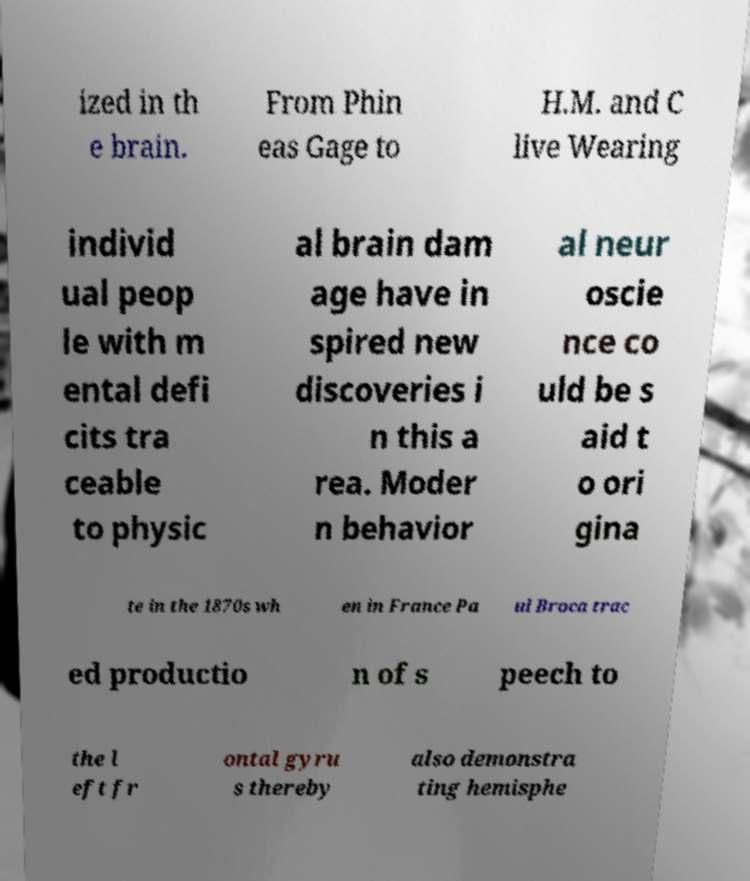There's text embedded in this image that I need extracted. Can you transcribe it verbatim? ized in th e brain. From Phin eas Gage to H.M. and C live Wearing individ ual peop le with m ental defi cits tra ceable to physic al brain dam age have in spired new discoveries i n this a rea. Moder n behavior al neur oscie nce co uld be s aid t o ori gina te in the 1870s wh en in France Pa ul Broca trac ed productio n of s peech to the l eft fr ontal gyru s thereby also demonstra ting hemisphe 